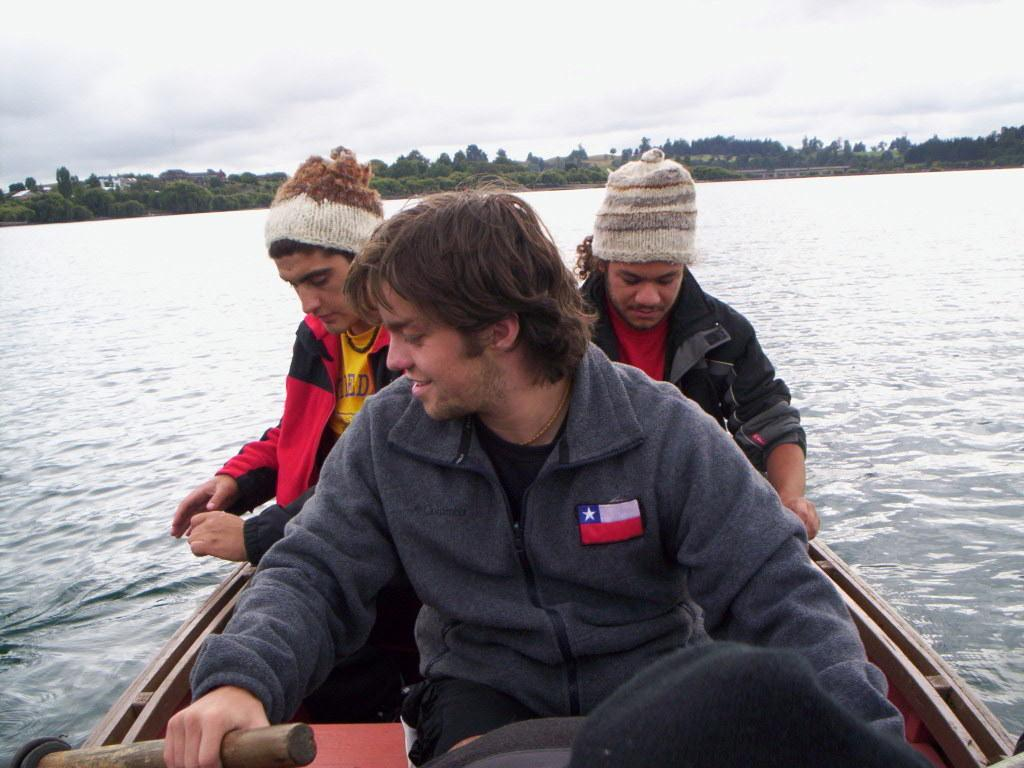How many people are in the boat in the image? There are three persons sitting in a boat in the image. What is the primary element surrounding the boat? There is water visible in the image. What type of vegetation can be seen in the image? There are trees in the image. What is visible above the boat and trees in the image? The sky is visible in the image. What type of crime is being committed in the image? There is no indication of a crime being committed in the image; it features a boat with three persons on the water. What question is being asked by the deer in the image? There are no deer present in the image, so no questions can be asked by a deer. 